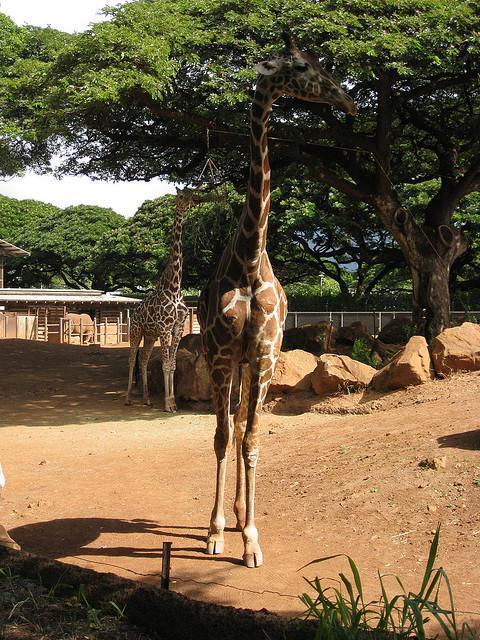How many animals are shown?
Give a very brief answer. 2. How many giraffes are there?
Give a very brief answer. 2. How many people are wearing an apron?
Give a very brief answer. 0. 